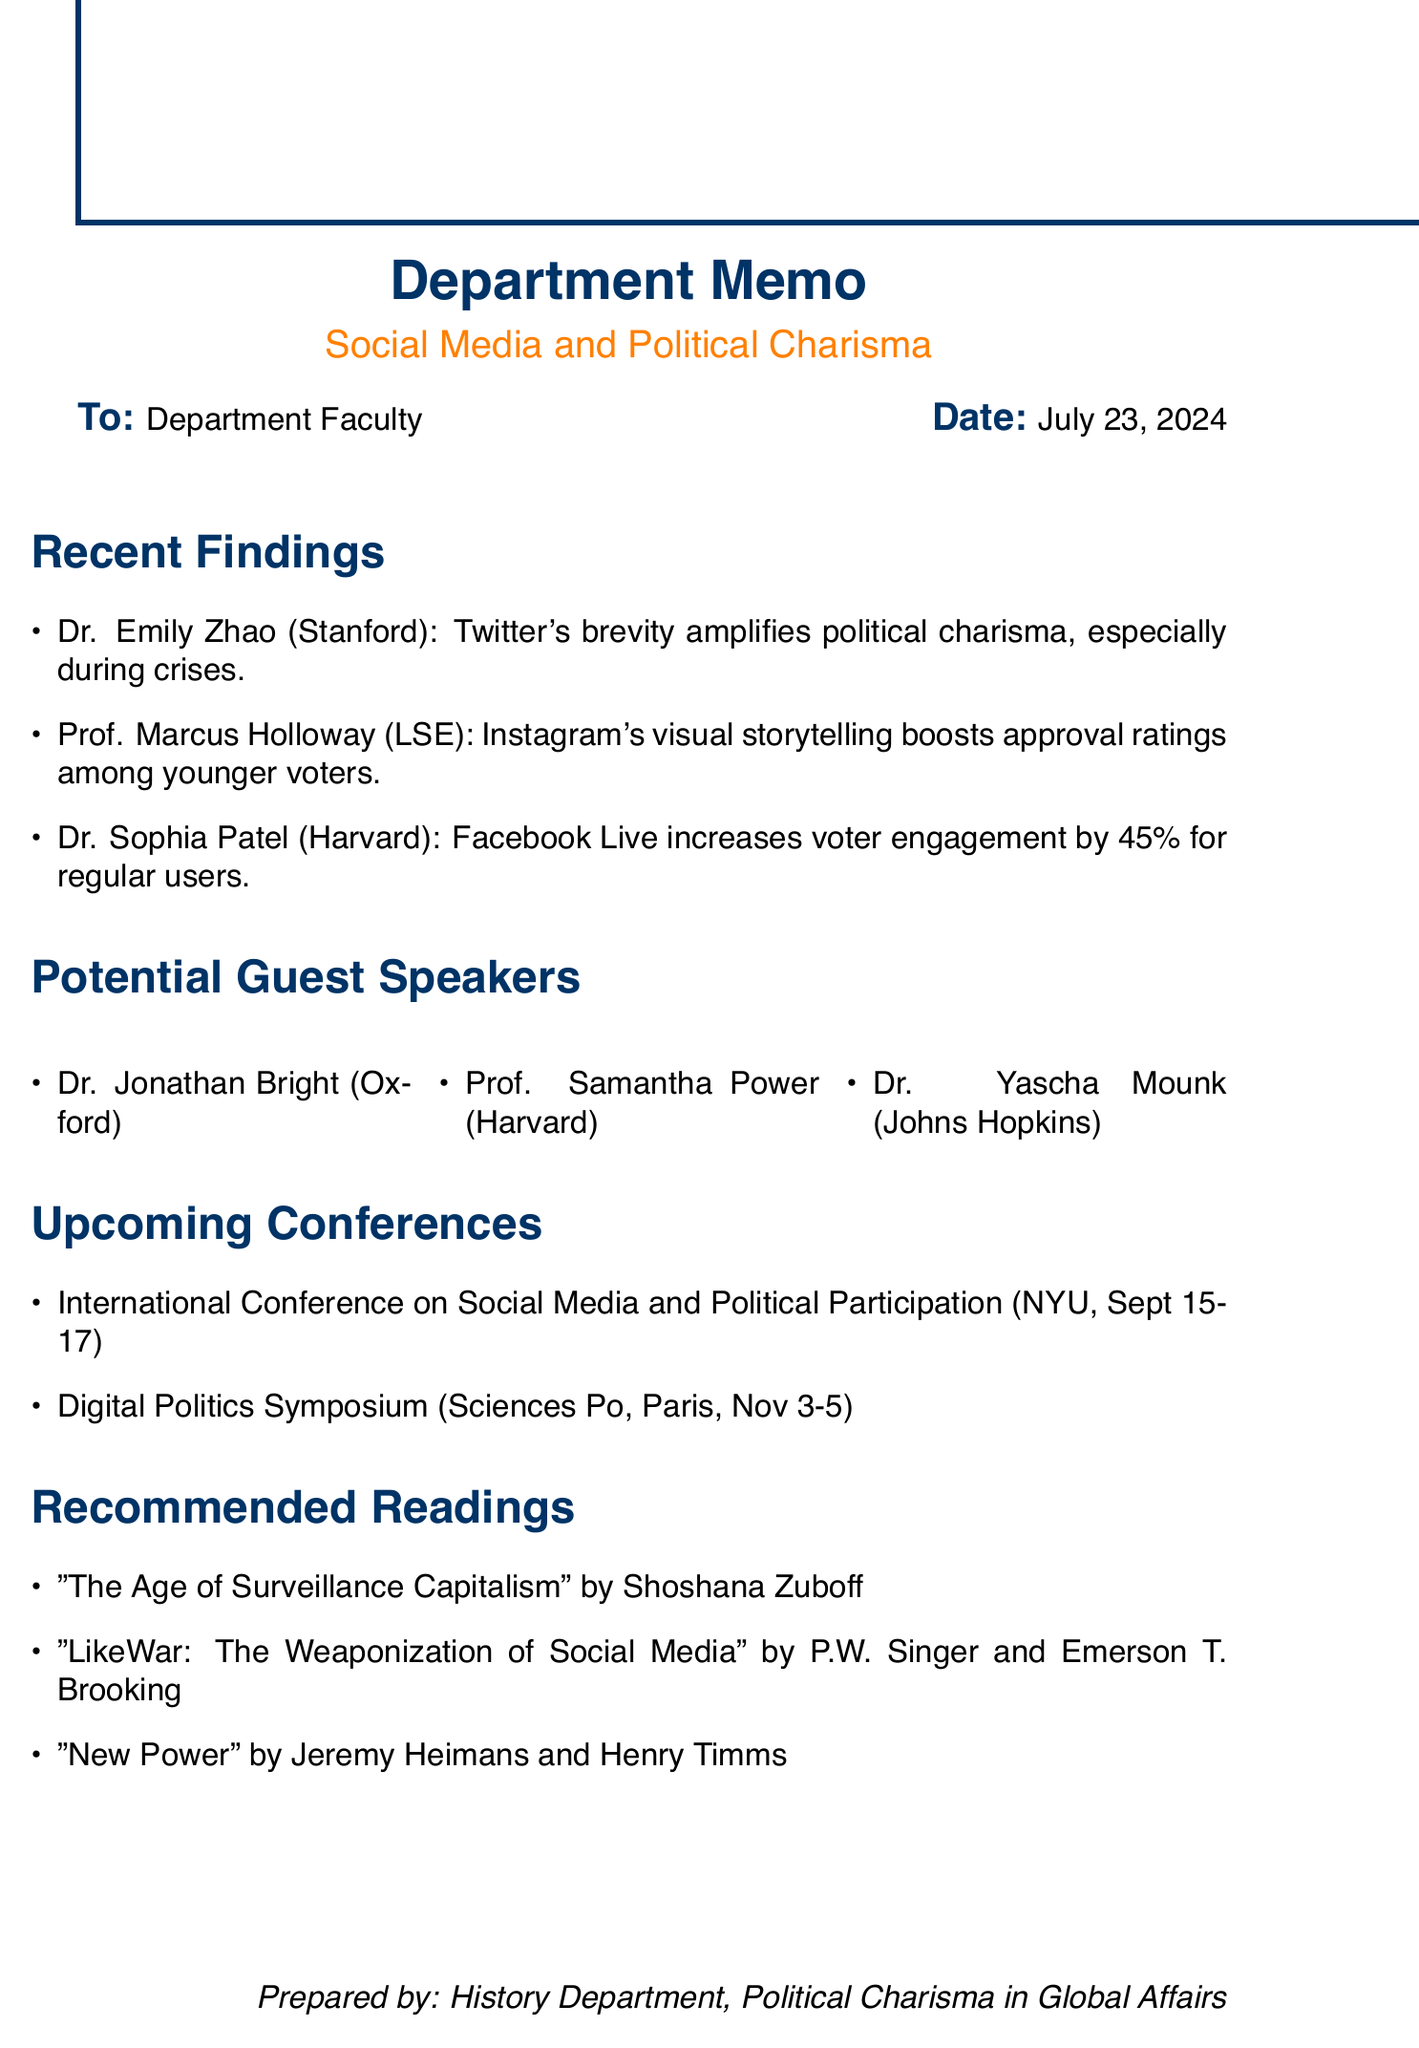What is the title of Dr. Emily Zhao's study? The title of Dr. Emily Zhao's study is mentioned in the recent findings section, specifically about the impact of Twitter on political charisma.
Answer: The Twitter Effect: How Social Media Amplifies Political Charisma Which social media platform is associated with a 45% increase in voter engagement? The document states that Facebook Live events lead to a significant increase in voter engagement for politicians who utilize this platform.
Answer: Facebook Live Who is the author of "The Age of Surveillance Capitalism"? The document lists this book under recommended readings with the author's name provided.
Answer: Shoshana Zuboff What is the date of the Digital Politics Symposium? The conference section provides the date for the upcoming Digital Politics Symposium.
Answer: November 3-5, 2023 Which expert's recent publication discusses digital politics? The potential guest speakers section includes Dr. Jonathan Bright, whose publication relates to digital politics.
Answer: The Digital Transformation of Charisma: Social Media and the Rise of Authentic Political Narratives How many recent findings are discussed in the memo? The recent findings section enumerates the studies presented, allowing for a straightforward count of the studies highlighted.
Answer: Three What is the main focus of the research by Prof. Marcus Holloway? The memo summarizes the content of Prof. Holloway's research, focusing on a specific aspect of social media and political charisma.
Answer: Visual storytelling Who is the keynote speaker at the International Conference on Social Media and Political Participation? The conference section specifies the keynote speaker for this particular event.
Answer: Dr. Zeynep Tufekci 